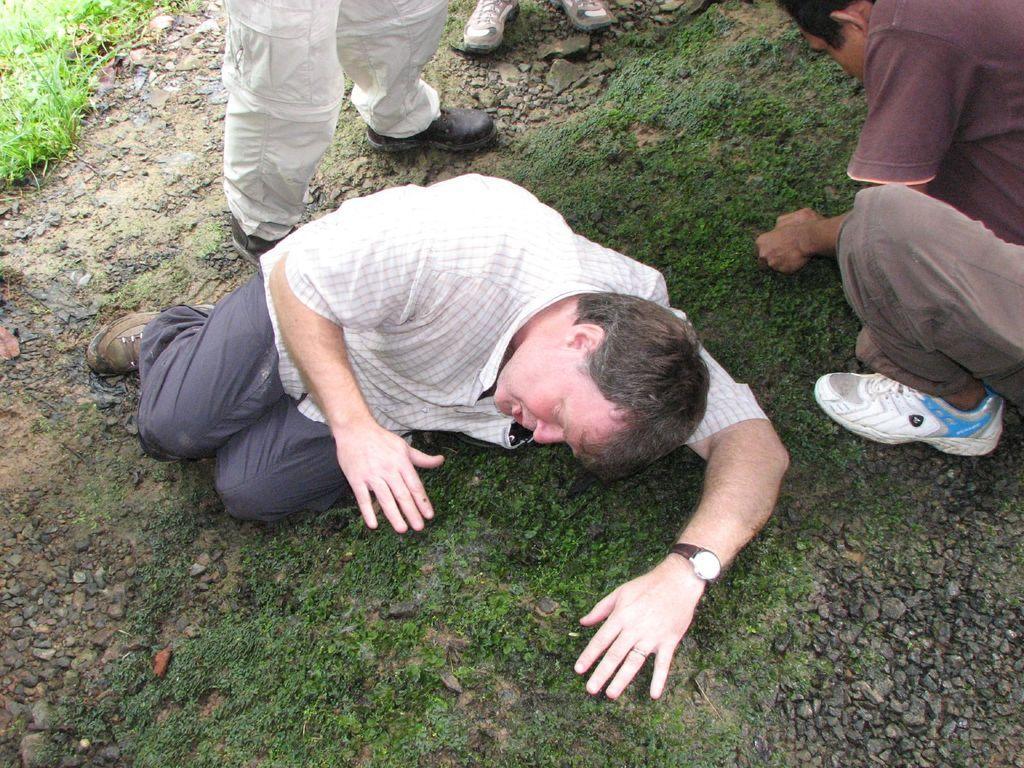Please provide a concise description of this image. In this picture we can see few people, stones and grass, in the middle of the image we can see a man, he is lying on the grass. 